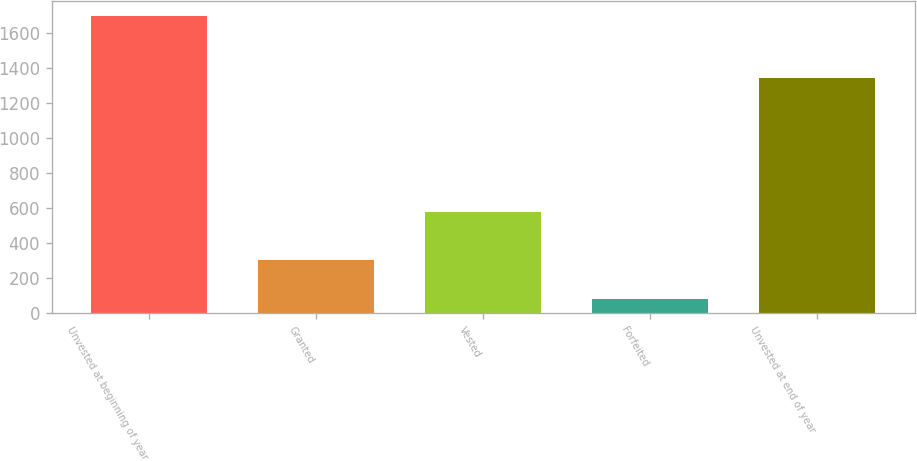<chart> <loc_0><loc_0><loc_500><loc_500><bar_chart><fcel>Unvested at beginning of year<fcel>Granted<fcel>Vested<fcel>Forfeited<fcel>Unvested at end of year<nl><fcel>1701<fcel>304<fcel>580<fcel>82<fcel>1343<nl></chart> 